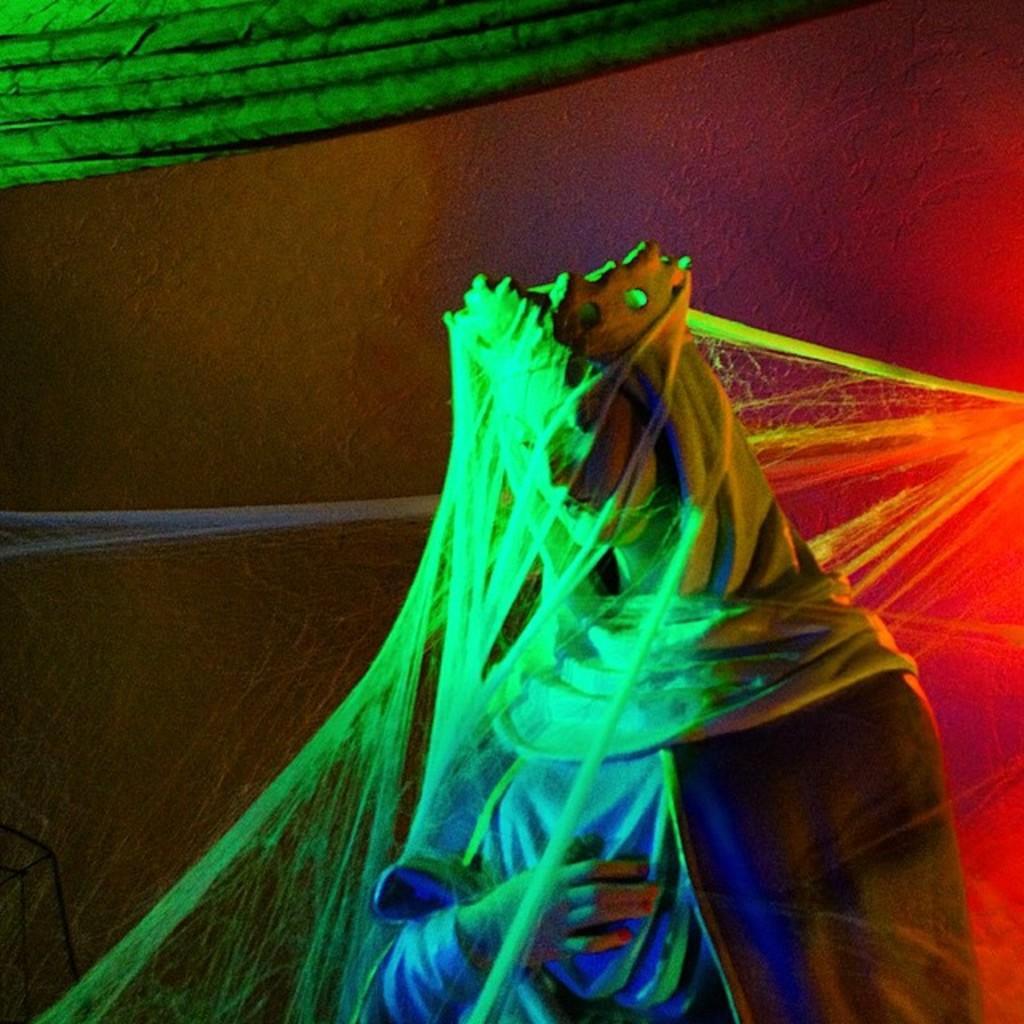Please provide a concise description of this image. In this image we can see a statue covered with web. On the top of the image we can see some curtain in green color. 